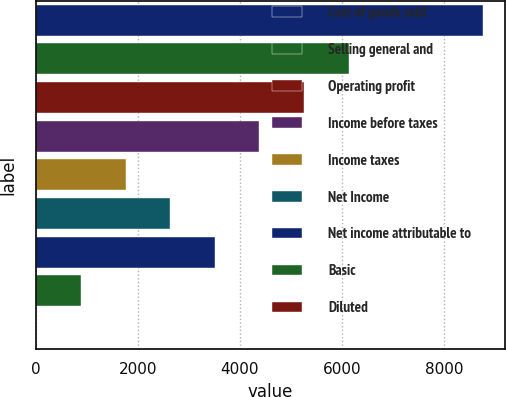Convert chart. <chart><loc_0><loc_0><loc_500><loc_500><bar_chart><fcel>Cost of goods sold<fcel>Selling general and<fcel>Operating profit<fcel>Income before taxes<fcel>Income taxes<fcel>Net Income<fcel>Net income attributable to<fcel>Basic<fcel>Diluted<nl><fcel>8763<fcel>6134.88<fcel>5258.85<fcel>4382.82<fcel>1754.73<fcel>2630.76<fcel>3506.79<fcel>878.7<fcel>2.67<nl></chart> 